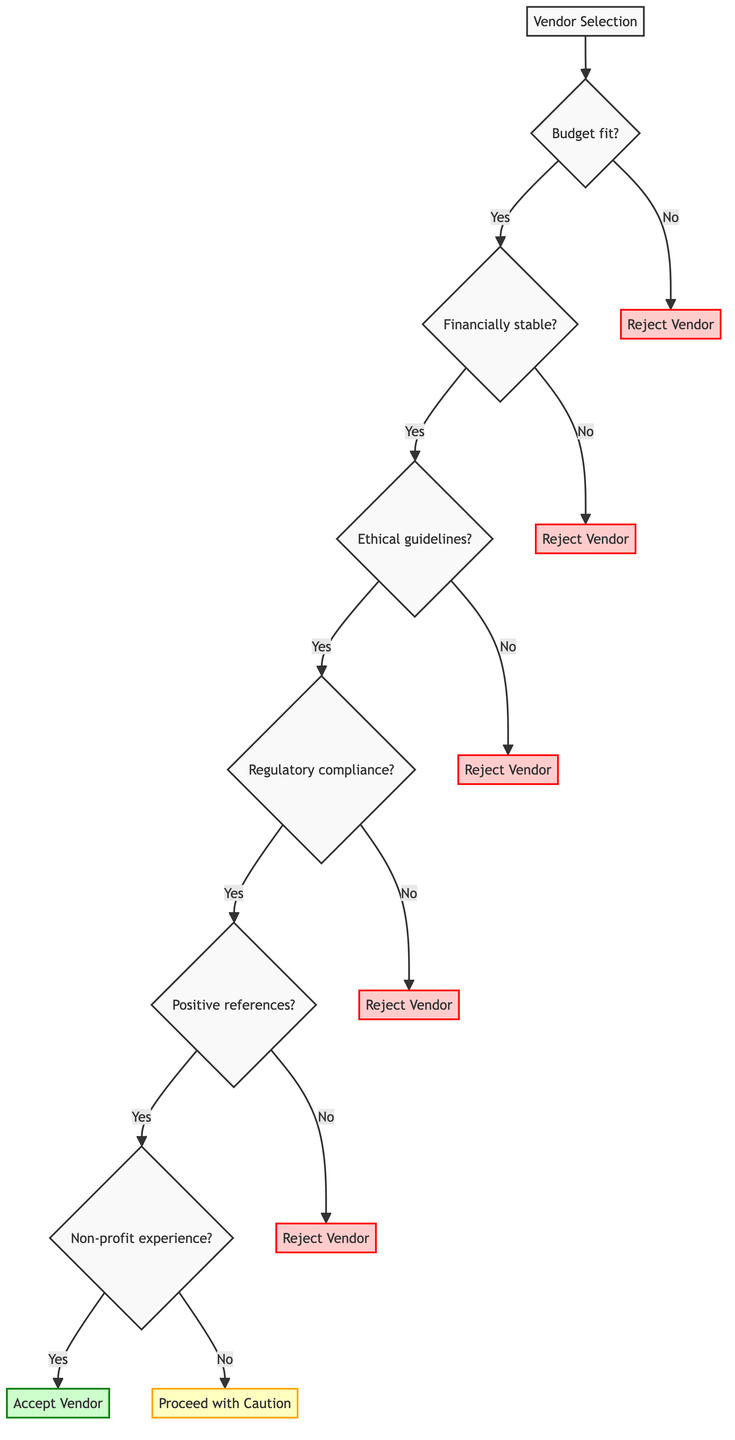What is the first question in the vendor selection process? The first question in the vendor selection process is about the budget fit. This leads to evaluating if the vendor's price aligns with the allocated budget.
Answer: Does the vendor's price fit within the allocated budget? How many decision points (questions) are there in the diagram? The diagram includes six decision points that evaluate various criteria for vendor selection before reaching a conclusion.
Answer: Six What happens if the vendor does not have positive references? If the vendor lacks positive references, the flow leads directly to rejecting the vendor, as indicated in the diagram.
Answer: Reject Vendor What is the outcome if the vendor fails to comply with regulatory requirements? The vendor will be rejected if they do not comply with relevant regulatory requirements; this is clear in the flow of the diagram.
Answer: Reject Vendor Does having non-profit experience guarantee vendor acceptance? No, if the vendor has non-profit experience, they can still be categorized as "Proceed with Caution," indicating that further evaluation may be necessary.
Answer: Proceed with Caution If a vendor meets all criteria, what is the final step? If a vendor meets all the outlined criteria, the final outcome is to accept the vendor, as per the last evaluation node in the diagram.
Answer: Accept Vendor What is the significance of ethical guidelines in the vendor selection process? Adherence to ethical guidelines is critical as failing this criterion leads directly to the vendor being rejected, highlighting its importance in the selection process.
Answer: Reject Vendor What decision is made if a vendor is not financially stable? If a vendor is not financially stable, they will be rejected in the selection process, which is indicated clearly in the decision paths of the diagram.
Answer: Reject Vendor 